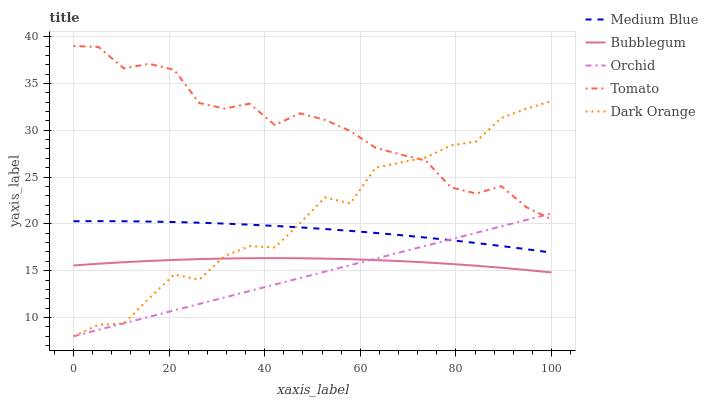Does Orchid have the minimum area under the curve?
Answer yes or no. Yes. Does Tomato have the maximum area under the curve?
Answer yes or no. Yes. Does Dark Orange have the minimum area under the curve?
Answer yes or no. No. Does Dark Orange have the maximum area under the curve?
Answer yes or no. No. Is Orchid the smoothest?
Answer yes or no. Yes. Is Tomato the roughest?
Answer yes or no. Yes. Is Dark Orange the smoothest?
Answer yes or no. No. Is Dark Orange the roughest?
Answer yes or no. No. Does Medium Blue have the lowest value?
Answer yes or no. No. Does Tomato have the highest value?
Answer yes or no. Yes. Does Dark Orange have the highest value?
Answer yes or no. No. Is Bubblegum less than Medium Blue?
Answer yes or no. Yes. Is Tomato greater than Medium Blue?
Answer yes or no. Yes. Does Bubblegum intersect Medium Blue?
Answer yes or no. No. 